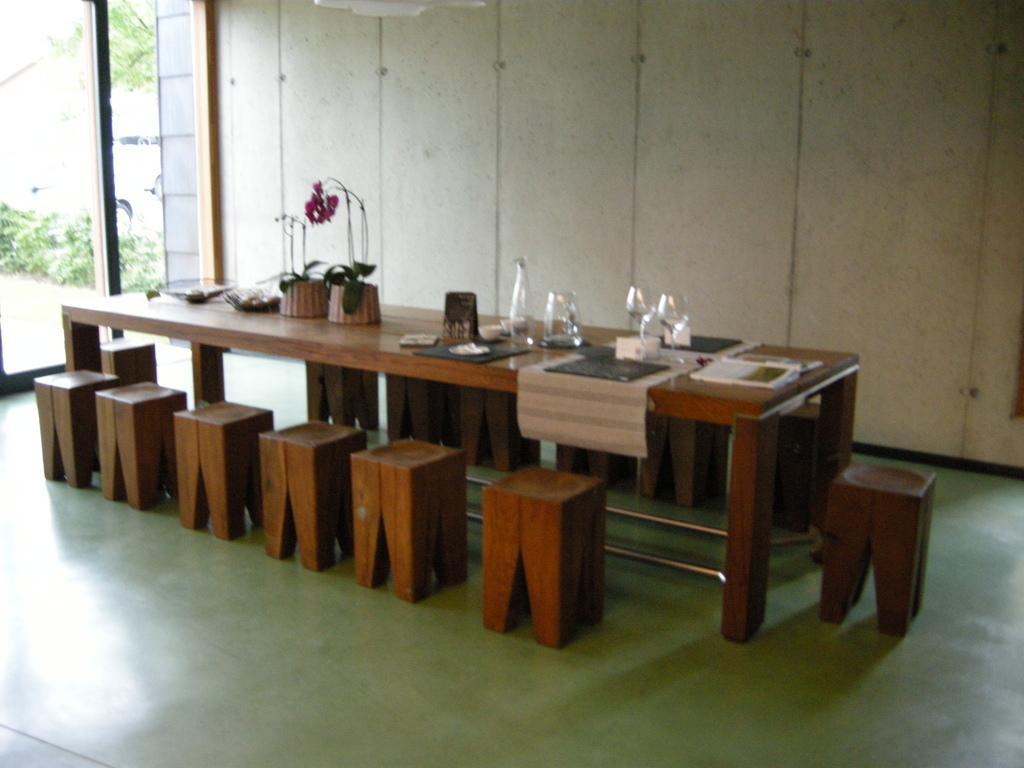In one or two sentences, can you explain what this image depicts? There are glasses, pots, a table and chairs are present in the middle of this image and there is a wall in the background. We can see a glass door on the left side of this image. 